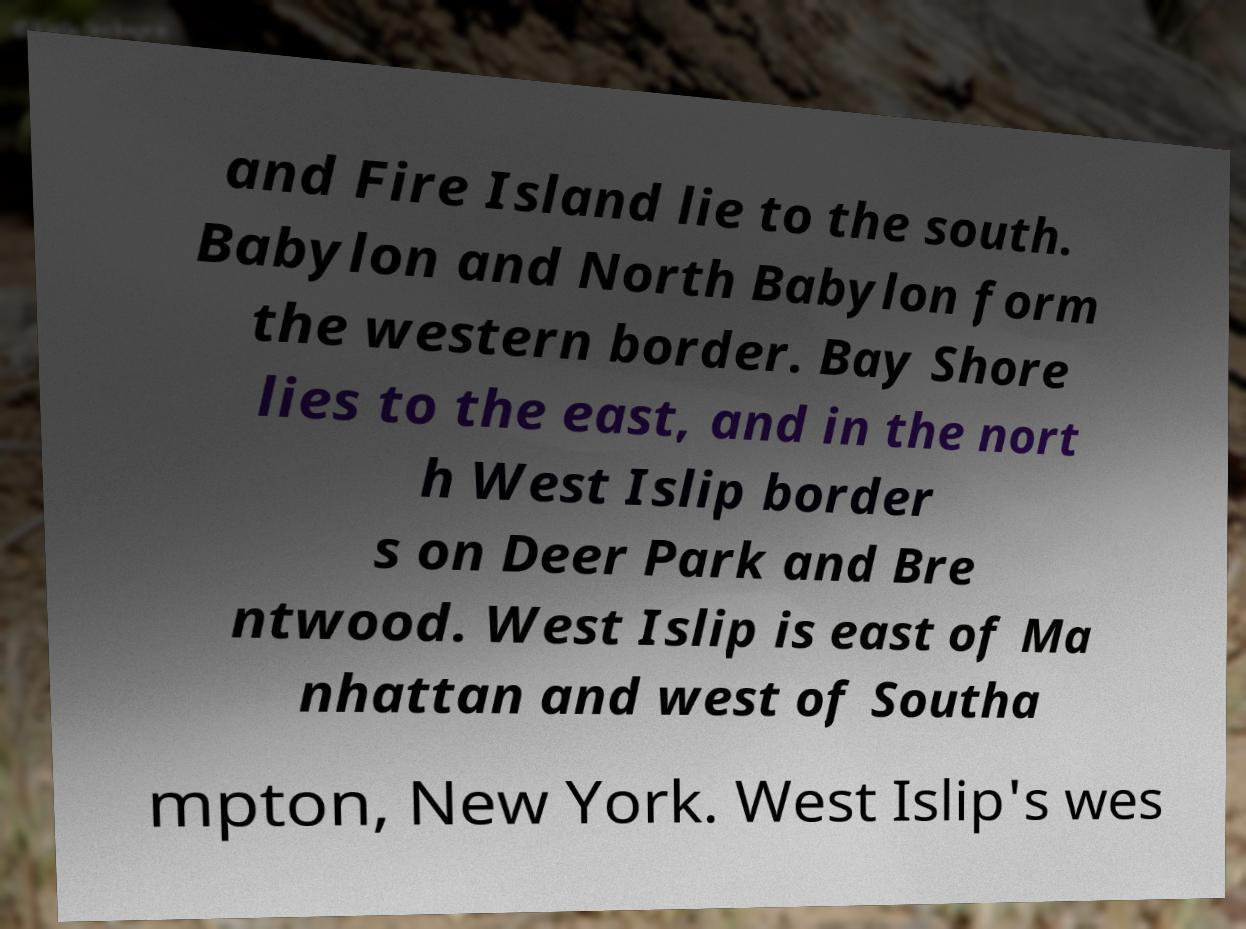For documentation purposes, I need the text within this image transcribed. Could you provide that? and Fire Island lie to the south. Babylon and North Babylon form the western border. Bay Shore lies to the east, and in the nort h West Islip border s on Deer Park and Bre ntwood. West Islip is east of Ma nhattan and west of Southa mpton, New York. West Islip's wes 